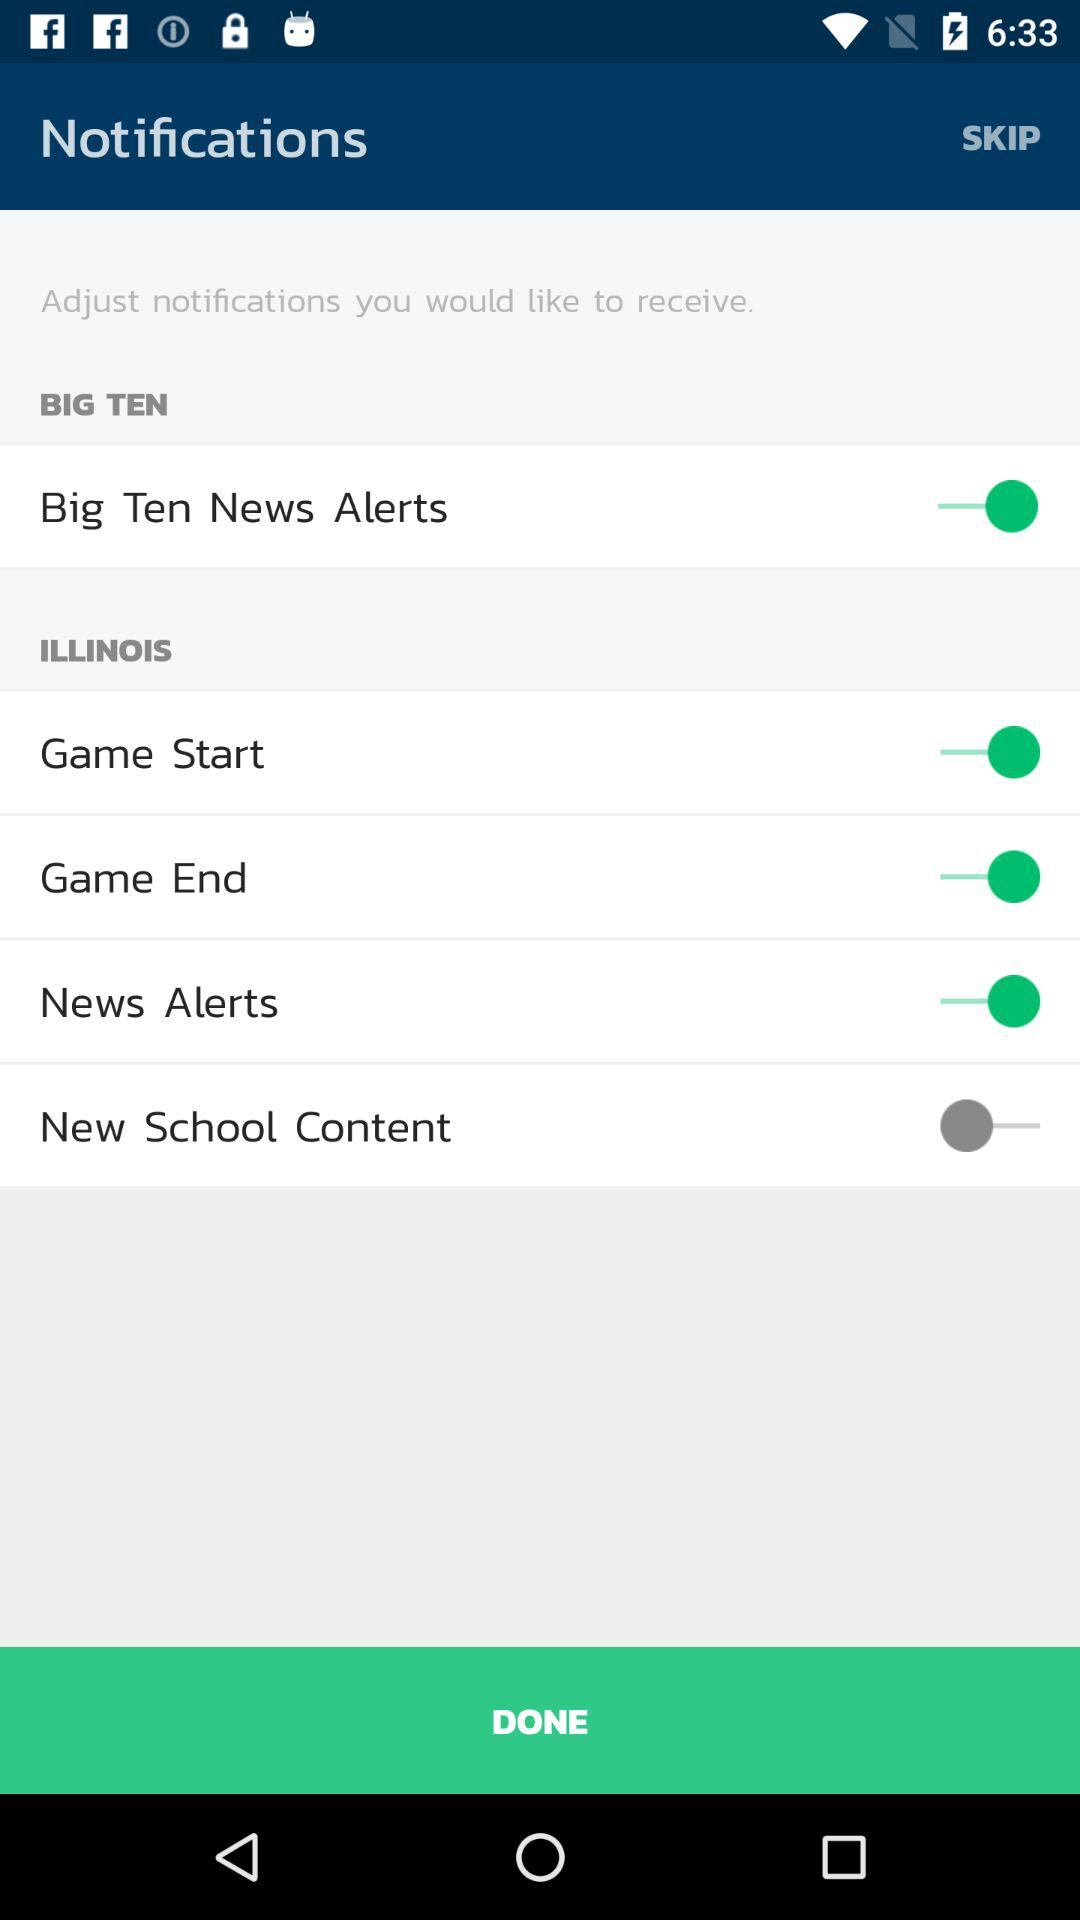How many items have a switch associated with them?
Answer the question using a single word or phrase. 5 